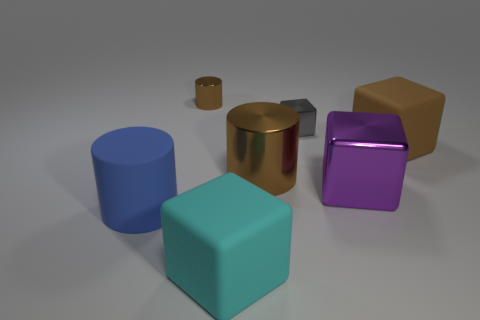What number of metal objects are in front of the big brown rubber object and left of the purple shiny cube?
Provide a short and direct response. 1. What number of things are large brown cubes or metallic things that are right of the small metallic cylinder?
Provide a succinct answer. 4. There is a large matte thing that is the same color as the small shiny cylinder; what shape is it?
Your answer should be compact. Cube. There is a shiny thing that is on the left side of the large cyan block; what color is it?
Give a very brief answer. Brown. How many things are shiny objects behind the big metallic cube or cubes?
Your response must be concise. 6. There is a shiny block that is the same size as the blue matte cylinder; what color is it?
Offer a very short reply. Purple. Is the number of matte things that are behind the big blue matte cylinder greater than the number of purple metallic objects?
Ensure brevity in your answer.  No. What is the big cube that is right of the large brown cylinder and in front of the large brown shiny object made of?
Your answer should be very brief. Metal. Do the tiny object on the left side of the small gray cube and the big thing that is on the right side of the big purple metal object have the same color?
Provide a short and direct response. Yes. How many other objects are the same size as the purple object?
Make the answer very short. 4. 